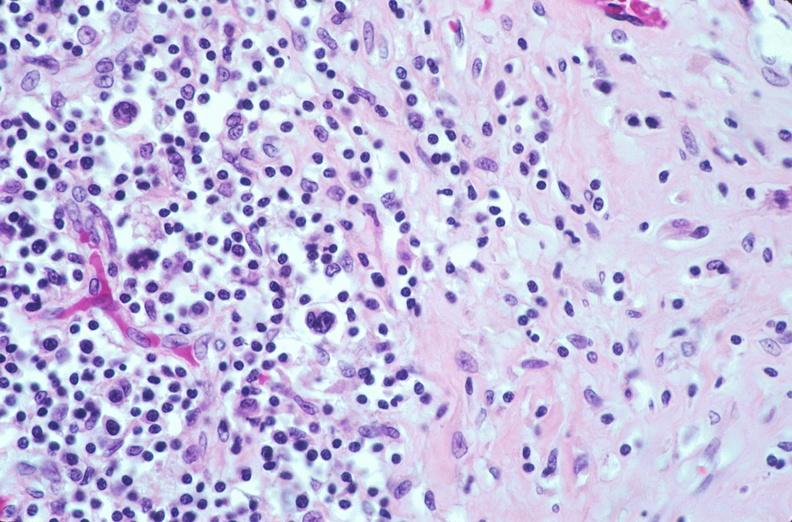what does this image show?
Answer the question using a single word or phrase. Lymph nodes 